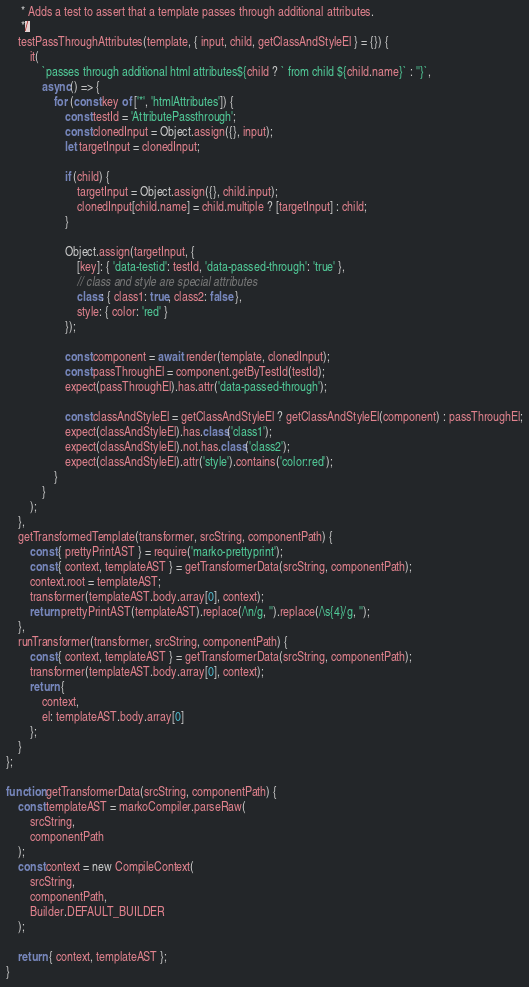Convert code to text. <code><loc_0><loc_0><loc_500><loc_500><_JavaScript_>     * Adds a test to assert that a template passes through additional attributes.
     */
    testPassThroughAttributes(template, { input, child, getClassAndStyleEl } = {}) {
        it(
            `passes through additional html attributes${child ? ` from child ${child.name}` : ''}`,
            async() => {
                for (const key of ['*', 'htmlAttributes']) {
                    const testId = 'AttributePassthrough';
                    const clonedInput = Object.assign({}, input);
                    let targetInput = clonedInput;

                    if (child) {
                        targetInput = Object.assign({}, child.input);
                        clonedInput[child.name] = child.multiple ? [targetInput] : child;
                    }

                    Object.assign(targetInput, {
                        [key]: { 'data-testid': testId, 'data-passed-through': 'true' },
                        // class and style are special attributes
                        class: { class1: true, class2: false },
                        style: { color: 'red' }
                    });

                    const component = await render(template, clonedInput);
                    const passThroughEl = component.getByTestId(testId);
                    expect(passThroughEl).has.attr('data-passed-through');

                    const classAndStyleEl = getClassAndStyleEl ? getClassAndStyleEl(component) : passThroughEl;
                    expect(classAndStyleEl).has.class('class1');
                    expect(classAndStyleEl).not.has.class('class2');
                    expect(classAndStyleEl).attr('style').contains('color:red');
                }
            }
        );
    },
    getTransformedTemplate(transformer, srcString, componentPath) {
        const { prettyPrintAST } = require('marko-prettyprint');
        const { context, templateAST } = getTransformerData(srcString, componentPath);
        context.root = templateAST;
        transformer(templateAST.body.array[0], context);
        return prettyPrintAST(templateAST).replace(/\n/g, '').replace(/\s{4}/g, '');
    },
    runTransformer(transformer, srcString, componentPath) {
        const { context, templateAST } = getTransformerData(srcString, componentPath);
        transformer(templateAST.body.array[0], context);
        return {
            context,
            el: templateAST.body.array[0]
        };
    }
};

function getTransformerData(srcString, componentPath) {
    const templateAST = markoCompiler.parseRaw(
        srcString,
        componentPath
    );
    const context = new CompileContext(
        srcString,
        componentPath,
        Builder.DEFAULT_BUILDER
    );

    return { context, templateAST };
}
</code> 